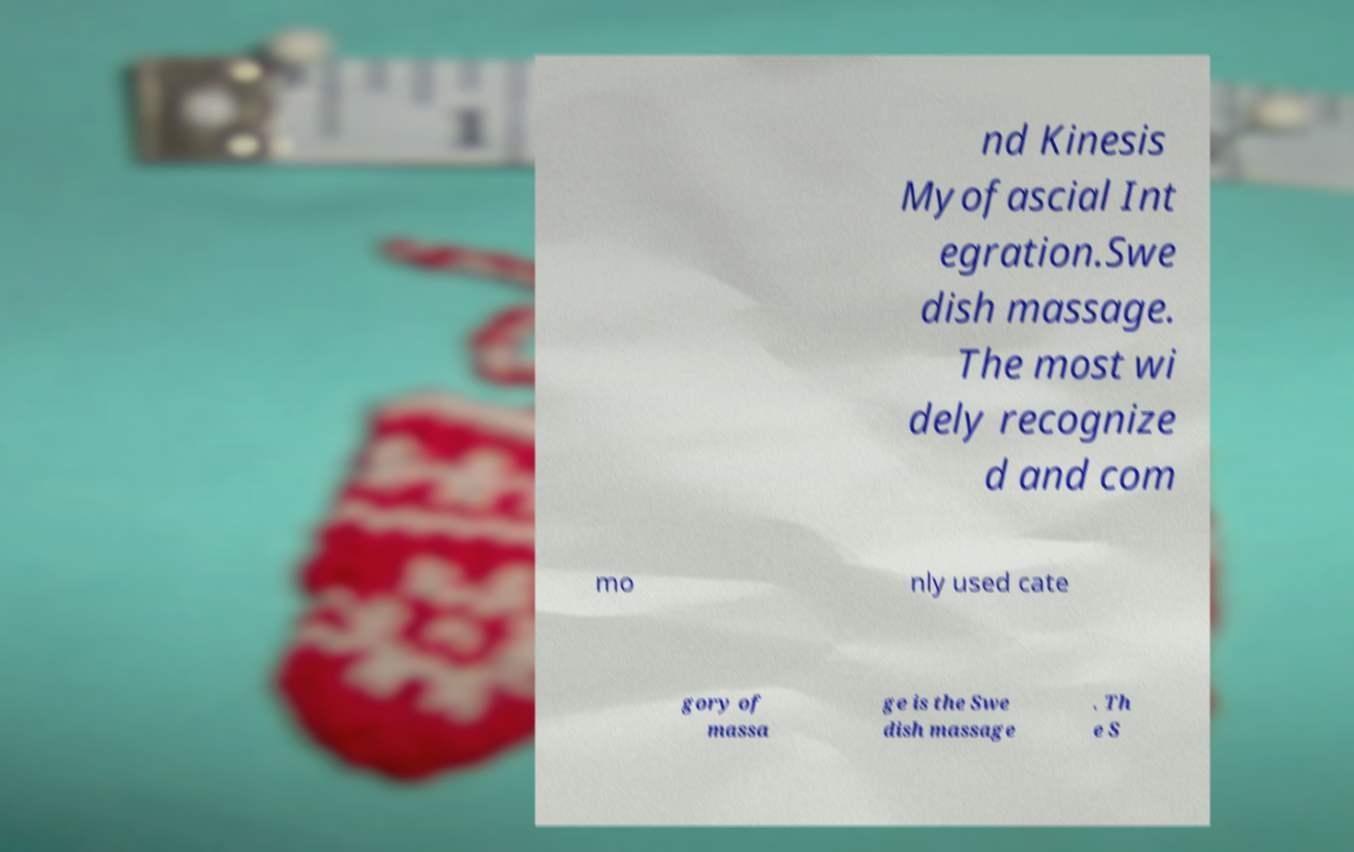For documentation purposes, I need the text within this image transcribed. Could you provide that? nd Kinesis Myofascial Int egration.Swe dish massage. The most wi dely recognize d and com mo nly used cate gory of massa ge is the Swe dish massage . Th e S 